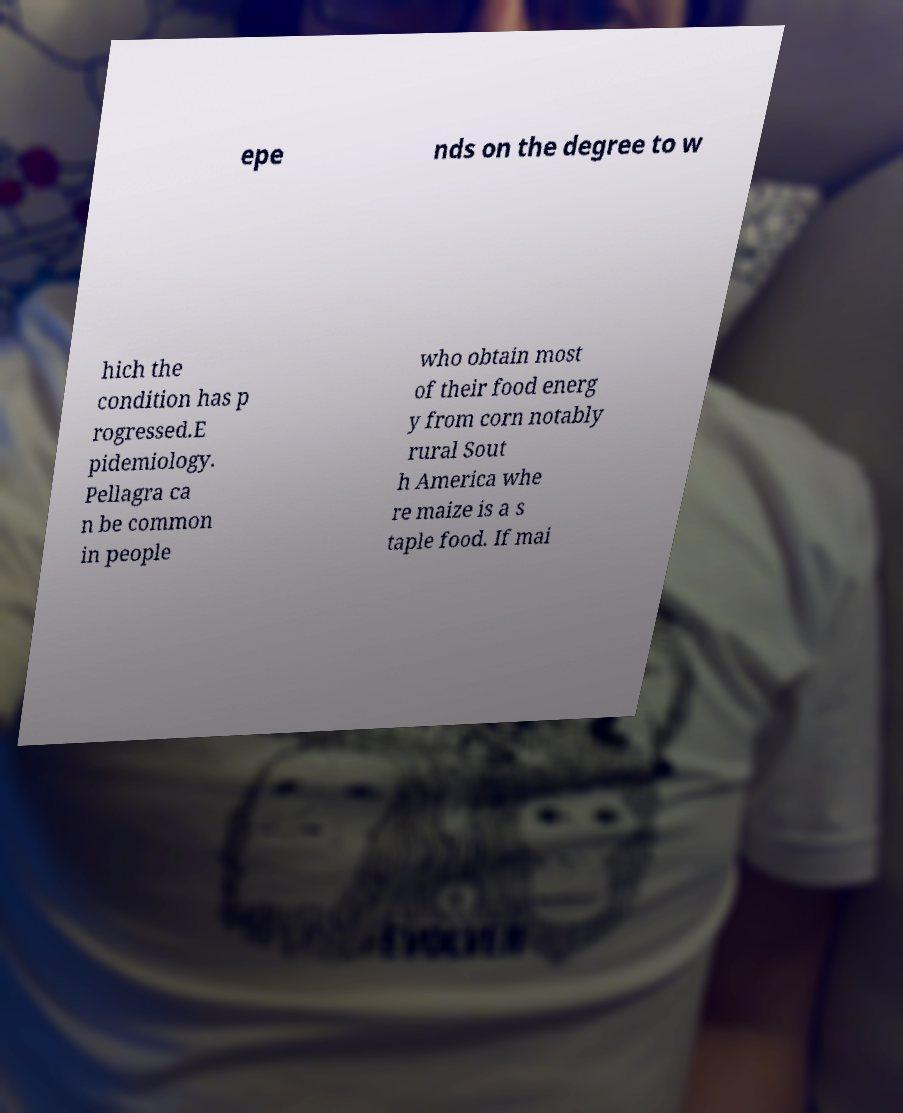Please read and relay the text visible in this image. What does it say? epe nds on the degree to w hich the condition has p rogressed.E pidemiology. Pellagra ca n be common in people who obtain most of their food energ y from corn notably rural Sout h America whe re maize is a s taple food. If mai 